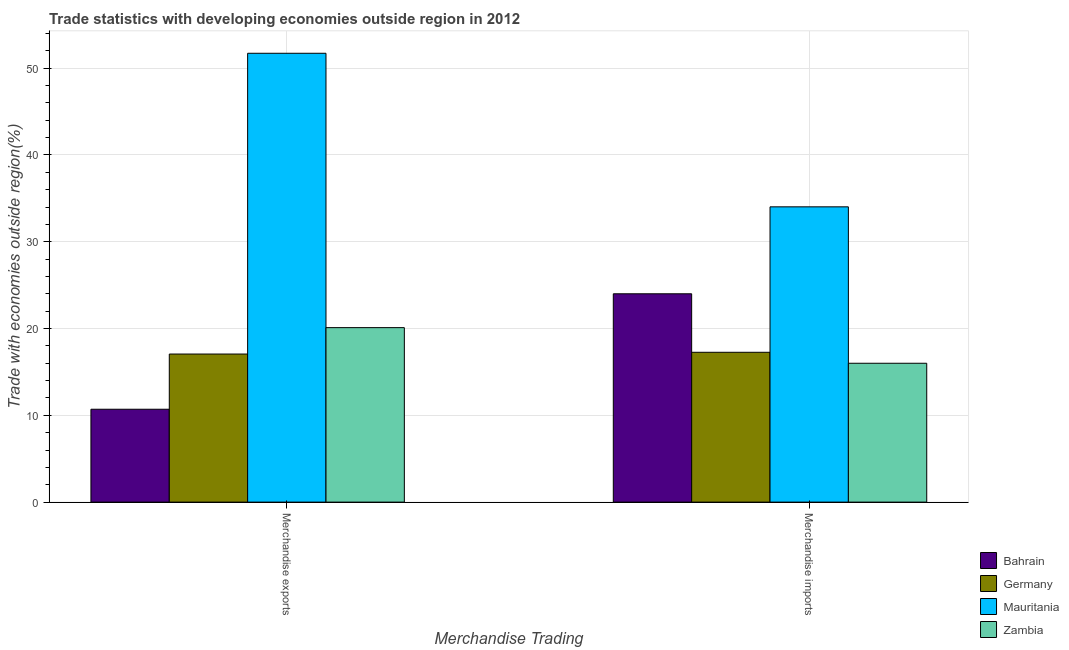How many groups of bars are there?
Keep it short and to the point. 2. Are the number of bars on each tick of the X-axis equal?
Make the answer very short. Yes. How many bars are there on the 1st tick from the left?
Offer a very short reply. 4. What is the label of the 2nd group of bars from the left?
Keep it short and to the point. Merchandise imports. What is the merchandise imports in Mauritania?
Keep it short and to the point. 34.02. Across all countries, what is the maximum merchandise imports?
Offer a terse response. 34.02. Across all countries, what is the minimum merchandise exports?
Provide a short and direct response. 10.7. In which country was the merchandise imports maximum?
Your answer should be compact. Mauritania. In which country was the merchandise imports minimum?
Provide a succinct answer. Zambia. What is the total merchandise exports in the graph?
Your answer should be compact. 99.58. What is the difference between the merchandise exports in Mauritania and that in Bahrain?
Your answer should be compact. 41.01. What is the difference between the merchandise imports in Zambia and the merchandise exports in Mauritania?
Keep it short and to the point. -35.71. What is the average merchandise imports per country?
Give a very brief answer. 22.82. What is the difference between the merchandise imports and merchandise exports in Bahrain?
Your response must be concise. 13.3. What is the ratio of the merchandise imports in Bahrain to that in Zambia?
Your response must be concise. 1.5. Is the merchandise exports in Germany less than that in Bahrain?
Your response must be concise. No. What does the 3rd bar from the left in Merchandise imports represents?
Your answer should be very brief. Mauritania. What does the 1st bar from the right in Merchandise exports represents?
Your answer should be very brief. Zambia. How many bars are there?
Provide a succinct answer. 8. How many countries are there in the graph?
Your answer should be compact. 4. Does the graph contain grids?
Make the answer very short. Yes. Where does the legend appear in the graph?
Provide a short and direct response. Bottom right. How many legend labels are there?
Your answer should be compact. 4. How are the legend labels stacked?
Your answer should be compact. Vertical. What is the title of the graph?
Provide a succinct answer. Trade statistics with developing economies outside region in 2012. Does "Seychelles" appear as one of the legend labels in the graph?
Provide a succinct answer. No. What is the label or title of the X-axis?
Your answer should be very brief. Merchandise Trading. What is the label or title of the Y-axis?
Ensure brevity in your answer.  Trade with economies outside region(%). What is the Trade with economies outside region(%) in Bahrain in Merchandise exports?
Offer a terse response. 10.7. What is the Trade with economies outside region(%) of Germany in Merchandise exports?
Make the answer very short. 17.06. What is the Trade with economies outside region(%) of Mauritania in Merchandise exports?
Provide a short and direct response. 51.71. What is the Trade with economies outside region(%) in Zambia in Merchandise exports?
Keep it short and to the point. 20.1. What is the Trade with economies outside region(%) in Bahrain in Merchandise imports?
Give a very brief answer. 24. What is the Trade with economies outside region(%) in Germany in Merchandise imports?
Keep it short and to the point. 17.26. What is the Trade with economies outside region(%) in Mauritania in Merchandise imports?
Keep it short and to the point. 34.02. What is the Trade with economies outside region(%) in Zambia in Merchandise imports?
Offer a terse response. 16. Across all Merchandise Trading, what is the maximum Trade with economies outside region(%) in Bahrain?
Provide a succinct answer. 24. Across all Merchandise Trading, what is the maximum Trade with economies outside region(%) in Germany?
Offer a terse response. 17.26. Across all Merchandise Trading, what is the maximum Trade with economies outside region(%) of Mauritania?
Your answer should be very brief. 51.71. Across all Merchandise Trading, what is the maximum Trade with economies outside region(%) in Zambia?
Keep it short and to the point. 20.1. Across all Merchandise Trading, what is the minimum Trade with economies outside region(%) in Bahrain?
Offer a very short reply. 10.7. Across all Merchandise Trading, what is the minimum Trade with economies outside region(%) of Germany?
Provide a short and direct response. 17.06. Across all Merchandise Trading, what is the minimum Trade with economies outside region(%) of Mauritania?
Make the answer very short. 34.02. Across all Merchandise Trading, what is the minimum Trade with economies outside region(%) of Zambia?
Ensure brevity in your answer.  16. What is the total Trade with economies outside region(%) in Bahrain in the graph?
Provide a succinct answer. 34.7. What is the total Trade with economies outside region(%) in Germany in the graph?
Keep it short and to the point. 34.32. What is the total Trade with economies outside region(%) of Mauritania in the graph?
Keep it short and to the point. 85.73. What is the total Trade with economies outside region(%) in Zambia in the graph?
Offer a very short reply. 36.1. What is the difference between the Trade with economies outside region(%) in Bahrain in Merchandise exports and that in Merchandise imports?
Ensure brevity in your answer.  -13.3. What is the difference between the Trade with economies outside region(%) in Germany in Merchandise exports and that in Merchandise imports?
Make the answer very short. -0.2. What is the difference between the Trade with economies outside region(%) in Mauritania in Merchandise exports and that in Merchandise imports?
Ensure brevity in your answer.  17.69. What is the difference between the Trade with economies outside region(%) in Zambia in Merchandise exports and that in Merchandise imports?
Offer a very short reply. 4.1. What is the difference between the Trade with economies outside region(%) of Bahrain in Merchandise exports and the Trade with economies outside region(%) of Germany in Merchandise imports?
Your answer should be compact. -6.56. What is the difference between the Trade with economies outside region(%) in Bahrain in Merchandise exports and the Trade with economies outside region(%) in Mauritania in Merchandise imports?
Give a very brief answer. -23.32. What is the difference between the Trade with economies outside region(%) in Bahrain in Merchandise exports and the Trade with economies outside region(%) in Zambia in Merchandise imports?
Give a very brief answer. -5.3. What is the difference between the Trade with economies outside region(%) in Germany in Merchandise exports and the Trade with economies outside region(%) in Mauritania in Merchandise imports?
Provide a short and direct response. -16.96. What is the difference between the Trade with economies outside region(%) of Germany in Merchandise exports and the Trade with economies outside region(%) of Zambia in Merchandise imports?
Make the answer very short. 1.06. What is the difference between the Trade with economies outside region(%) of Mauritania in Merchandise exports and the Trade with economies outside region(%) of Zambia in Merchandise imports?
Your response must be concise. 35.71. What is the average Trade with economies outside region(%) of Bahrain per Merchandise Trading?
Your response must be concise. 17.35. What is the average Trade with economies outside region(%) in Germany per Merchandise Trading?
Your response must be concise. 17.16. What is the average Trade with economies outside region(%) of Mauritania per Merchandise Trading?
Your response must be concise. 42.87. What is the average Trade with economies outside region(%) of Zambia per Merchandise Trading?
Your answer should be compact. 18.05. What is the difference between the Trade with economies outside region(%) of Bahrain and Trade with economies outside region(%) of Germany in Merchandise exports?
Make the answer very short. -6.36. What is the difference between the Trade with economies outside region(%) of Bahrain and Trade with economies outside region(%) of Mauritania in Merchandise exports?
Provide a succinct answer. -41.01. What is the difference between the Trade with economies outside region(%) of Bahrain and Trade with economies outside region(%) of Zambia in Merchandise exports?
Your response must be concise. -9.4. What is the difference between the Trade with economies outside region(%) of Germany and Trade with economies outside region(%) of Mauritania in Merchandise exports?
Provide a succinct answer. -34.65. What is the difference between the Trade with economies outside region(%) in Germany and Trade with economies outside region(%) in Zambia in Merchandise exports?
Provide a short and direct response. -3.04. What is the difference between the Trade with economies outside region(%) of Mauritania and Trade with economies outside region(%) of Zambia in Merchandise exports?
Provide a succinct answer. 31.61. What is the difference between the Trade with economies outside region(%) in Bahrain and Trade with economies outside region(%) in Germany in Merchandise imports?
Your answer should be very brief. 6.74. What is the difference between the Trade with economies outside region(%) in Bahrain and Trade with economies outside region(%) in Mauritania in Merchandise imports?
Ensure brevity in your answer.  -10.02. What is the difference between the Trade with economies outside region(%) in Bahrain and Trade with economies outside region(%) in Zambia in Merchandise imports?
Keep it short and to the point. 8. What is the difference between the Trade with economies outside region(%) of Germany and Trade with economies outside region(%) of Mauritania in Merchandise imports?
Your response must be concise. -16.76. What is the difference between the Trade with economies outside region(%) of Germany and Trade with economies outside region(%) of Zambia in Merchandise imports?
Offer a very short reply. 1.26. What is the difference between the Trade with economies outside region(%) of Mauritania and Trade with economies outside region(%) of Zambia in Merchandise imports?
Keep it short and to the point. 18.02. What is the ratio of the Trade with economies outside region(%) of Bahrain in Merchandise exports to that in Merchandise imports?
Make the answer very short. 0.45. What is the ratio of the Trade with economies outside region(%) of Germany in Merchandise exports to that in Merchandise imports?
Make the answer very short. 0.99. What is the ratio of the Trade with economies outside region(%) of Mauritania in Merchandise exports to that in Merchandise imports?
Provide a short and direct response. 1.52. What is the ratio of the Trade with economies outside region(%) of Zambia in Merchandise exports to that in Merchandise imports?
Your answer should be very brief. 1.26. What is the difference between the highest and the second highest Trade with economies outside region(%) in Bahrain?
Offer a very short reply. 13.3. What is the difference between the highest and the second highest Trade with economies outside region(%) in Germany?
Provide a short and direct response. 0.2. What is the difference between the highest and the second highest Trade with economies outside region(%) in Mauritania?
Give a very brief answer. 17.69. What is the difference between the highest and the second highest Trade with economies outside region(%) of Zambia?
Offer a very short reply. 4.1. What is the difference between the highest and the lowest Trade with economies outside region(%) of Bahrain?
Give a very brief answer. 13.3. What is the difference between the highest and the lowest Trade with economies outside region(%) of Germany?
Your response must be concise. 0.2. What is the difference between the highest and the lowest Trade with economies outside region(%) of Mauritania?
Your answer should be very brief. 17.69. What is the difference between the highest and the lowest Trade with economies outside region(%) of Zambia?
Keep it short and to the point. 4.1. 